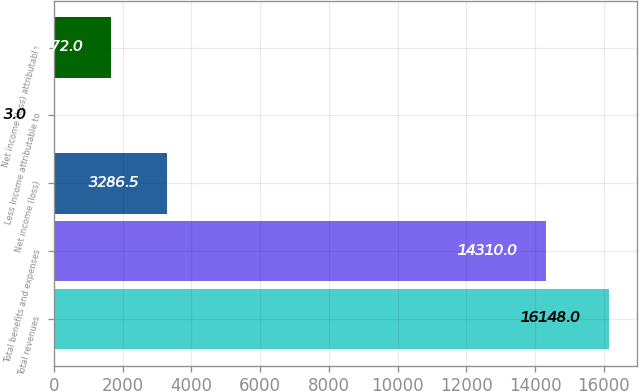Convert chart. <chart><loc_0><loc_0><loc_500><loc_500><bar_chart><fcel>Total revenues<fcel>Total benefits and expenses<fcel>Net income (loss)<fcel>Less Income attributable to<fcel>Net income (loss) attributable<nl><fcel>16148<fcel>14310<fcel>3286.5<fcel>3<fcel>1672<nl></chart> 